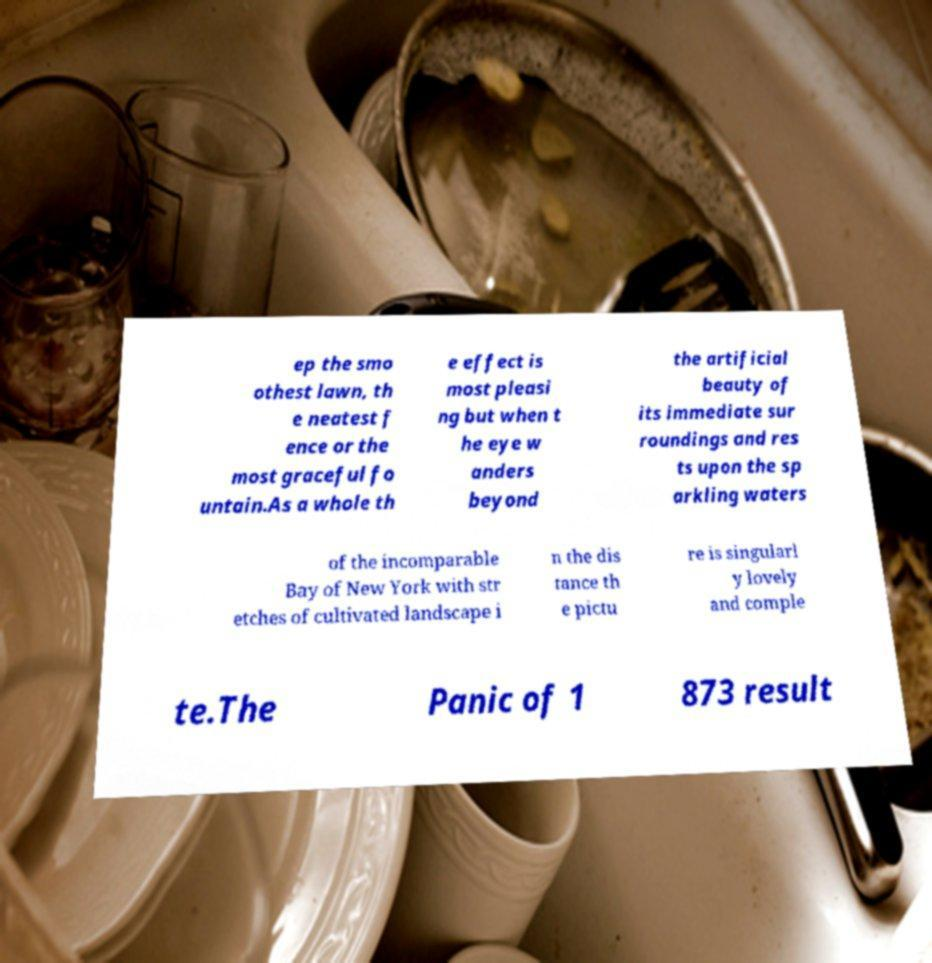What messages or text are displayed in this image? I need them in a readable, typed format. ep the smo othest lawn, th e neatest f ence or the most graceful fo untain.As a whole th e effect is most pleasi ng but when t he eye w anders beyond the artificial beauty of its immediate sur roundings and res ts upon the sp arkling waters of the incomparable Bay of New York with str etches of cultivated landscape i n the dis tance th e pictu re is singularl y lovely and comple te.The Panic of 1 873 result 